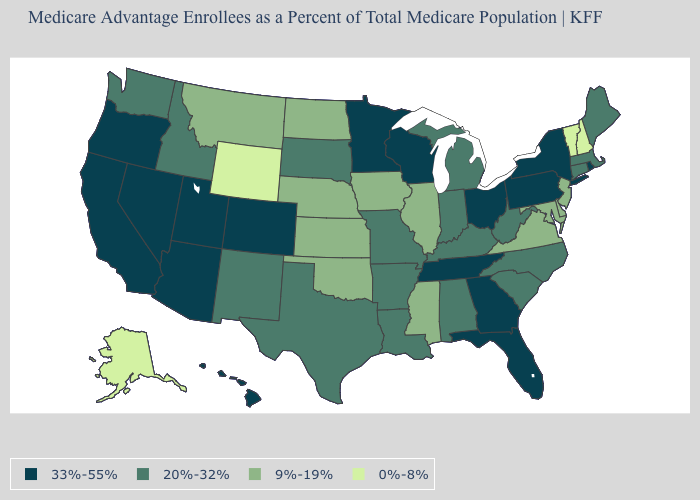Does New Mexico have the highest value in the West?
Write a very short answer. No. How many symbols are there in the legend?
Be succinct. 4. What is the value of Idaho?
Short answer required. 20%-32%. Which states have the highest value in the USA?
Short answer required. Arizona, California, Colorado, Florida, Georgia, Hawaii, Minnesota, Nevada, New York, Ohio, Oregon, Pennsylvania, Rhode Island, Tennessee, Utah, Wisconsin. Name the states that have a value in the range 20%-32%?
Be succinct. Alabama, Arkansas, Connecticut, Idaho, Indiana, Kentucky, Louisiana, Massachusetts, Maine, Michigan, Missouri, North Carolina, New Mexico, South Carolina, South Dakota, Texas, Washington, West Virginia. Name the states that have a value in the range 9%-19%?
Short answer required. Delaware, Iowa, Illinois, Kansas, Maryland, Mississippi, Montana, North Dakota, Nebraska, New Jersey, Oklahoma, Virginia. What is the highest value in the MidWest ?
Short answer required. 33%-55%. Does the map have missing data?
Write a very short answer. No. Among the states that border New Jersey , which have the lowest value?
Short answer required. Delaware. What is the highest value in the Northeast ?
Concise answer only. 33%-55%. Name the states that have a value in the range 9%-19%?
Answer briefly. Delaware, Iowa, Illinois, Kansas, Maryland, Mississippi, Montana, North Dakota, Nebraska, New Jersey, Oklahoma, Virginia. Which states have the lowest value in the MidWest?
Give a very brief answer. Iowa, Illinois, Kansas, North Dakota, Nebraska. What is the value of Wyoming?
Short answer required. 0%-8%. Which states have the lowest value in the Northeast?
Give a very brief answer. New Hampshire, Vermont. Name the states that have a value in the range 9%-19%?
Quick response, please. Delaware, Iowa, Illinois, Kansas, Maryland, Mississippi, Montana, North Dakota, Nebraska, New Jersey, Oklahoma, Virginia. 